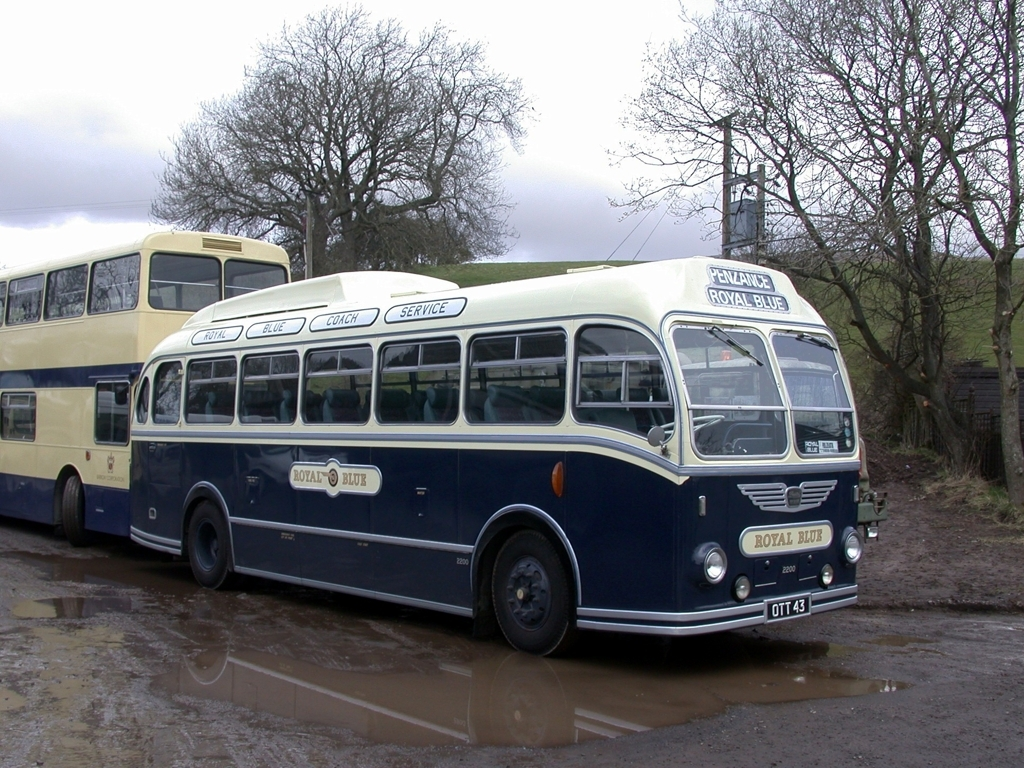Are the colors natural? After assessing the image, it can be confirmed that the colors appear natural and are indicative of the typical hues one would expect from vintage buses such as these, reflecting an authentic representation of their era. 